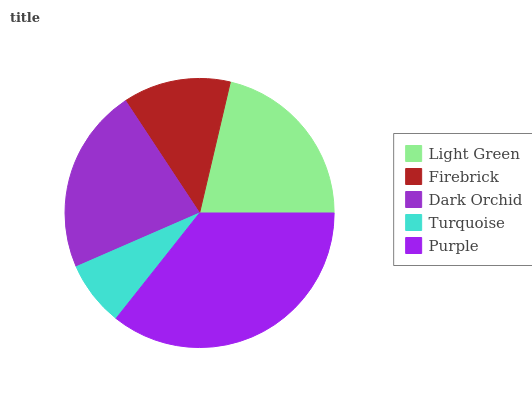Is Turquoise the minimum?
Answer yes or no. Yes. Is Purple the maximum?
Answer yes or no. Yes. Is Firebrick the minimum?
Answer yes or no. No. Is Firebrick the maximum?
Answer yes or no. No. Is Light Green greater than Firebrick?
Answer yes or no. Yes. Is Firebrick less than Light Green?
Answer yes or no. Yes. Is Firebrick greater than Light Green?
Answer yes or no. No. Is Light Green less than Firebrick?
Answer yes or no. No. Is Light Green the high median?
Answer yes or no. Yes. Is Light Green the low median?
Answer yes or no. Yes. Is Turquoise the high median?
Answer yes or no. No. Is Turquoise the low median?
Answer yes or no. No. 